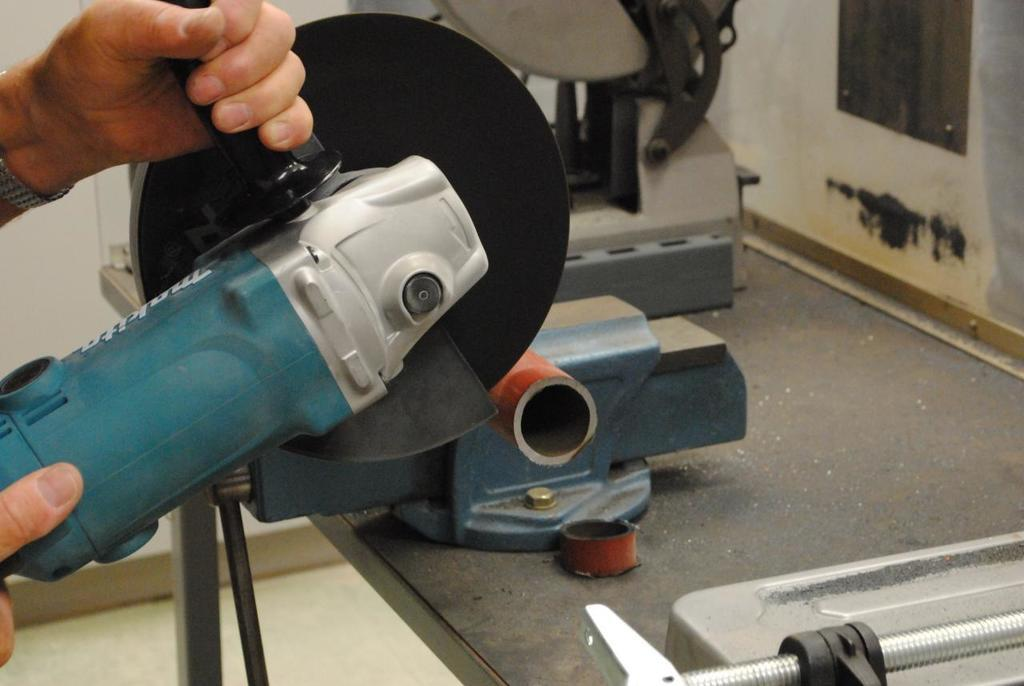What is the person in the image doing? The person is holding an angle grinder. What can be seen beneath the person's feet in the image? There is a floor visible in the image. What else is present in the image besides the person and the angle grinder? There are objects in the image. What is visible in the background of the image? There is a wall in the background of the image. What type of cakes can be seen on the giraffe's back in the image? There is no giraffe or cakes present in the image. Is there any steam visible coming from the angle grinder in the image? There is no steam visible coming from the angle grinder in the image. 